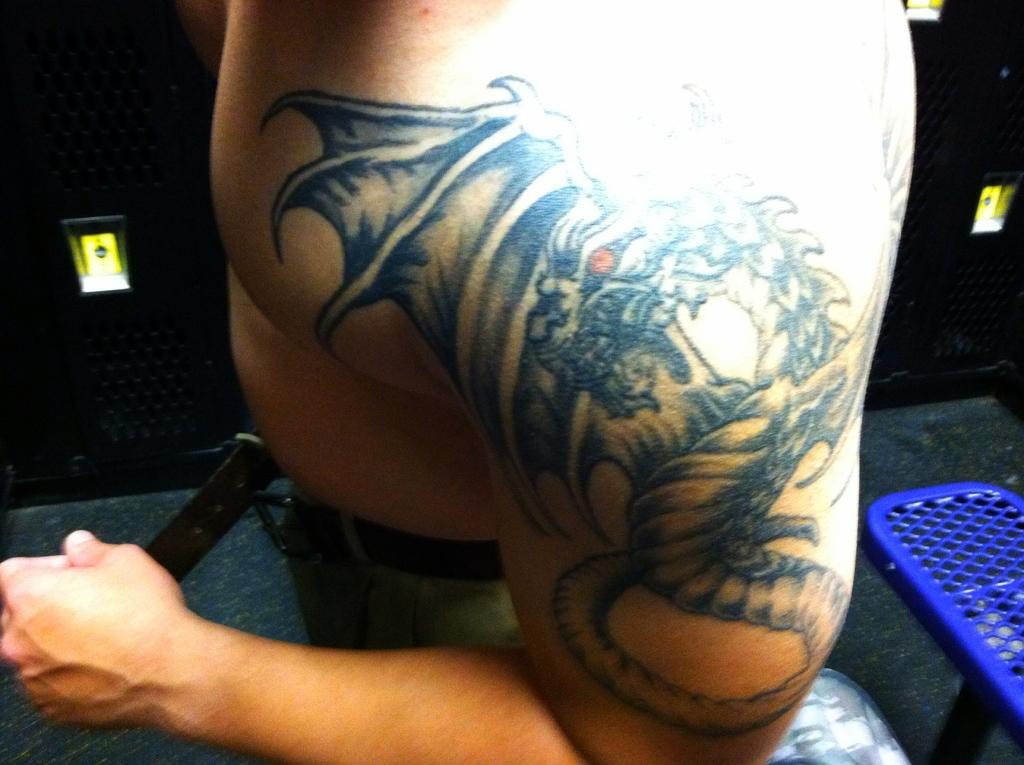What is visible on the person's shoulder in the image? There is a tattoo on a person's shoulder in the image. Where is the tattoo located in relation to the rest of the image? The tattoo is in the foreground area of the image. What can be seen in the background of the image? There are objects in the background of the image. What type of ship can be seen sailing in the background of the image? There is no ship visible in the image; it only features a tattoo on a person's shoulder and objects in the background. Who is the writer of the book that can be seen in the person's hand in the image? There is no book or writer mentioned in the image; it only features a tattoo on a person's shoulder and objects in the background. 